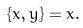Convert formula to latex. <formula><loc_0><loc_0><loc_500><loc_500>\{ x , y \} = x .</formula> 